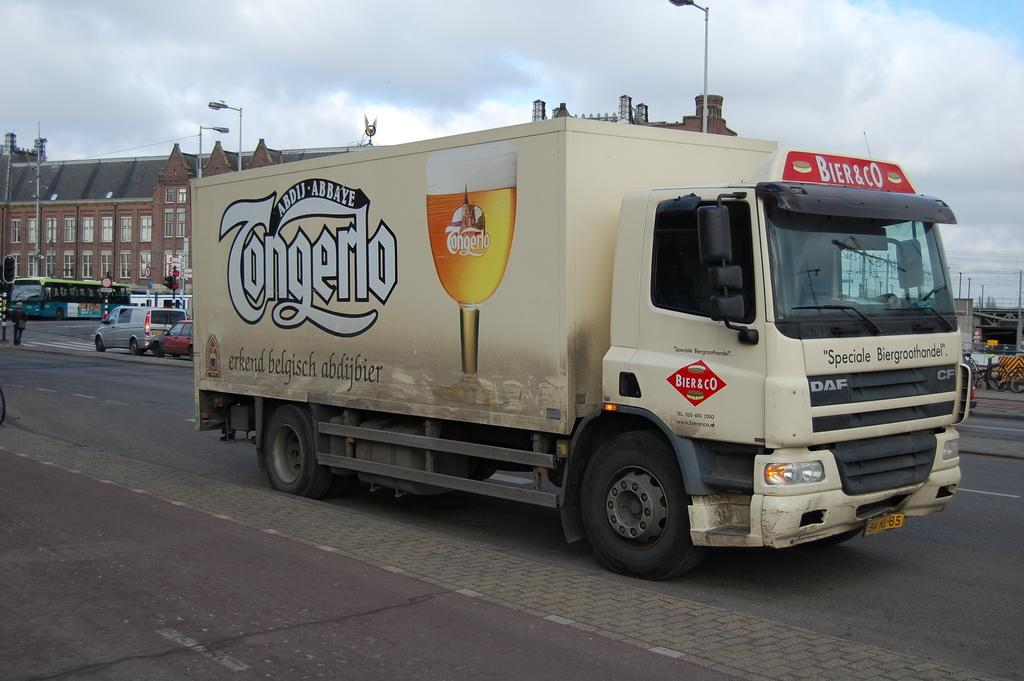What type of vehicle is on the road in the image? There is a truck on the road in the image. Are there any other vehicles in the image? Yes, there are vehicles behind the truck. What can be seen in the background of the image? There is a building in the background. What types of toys are the pets playing with in the image? There are no toys or pets present in the image; it features a truck on the road and vehicles behind it, with a building in the background. 